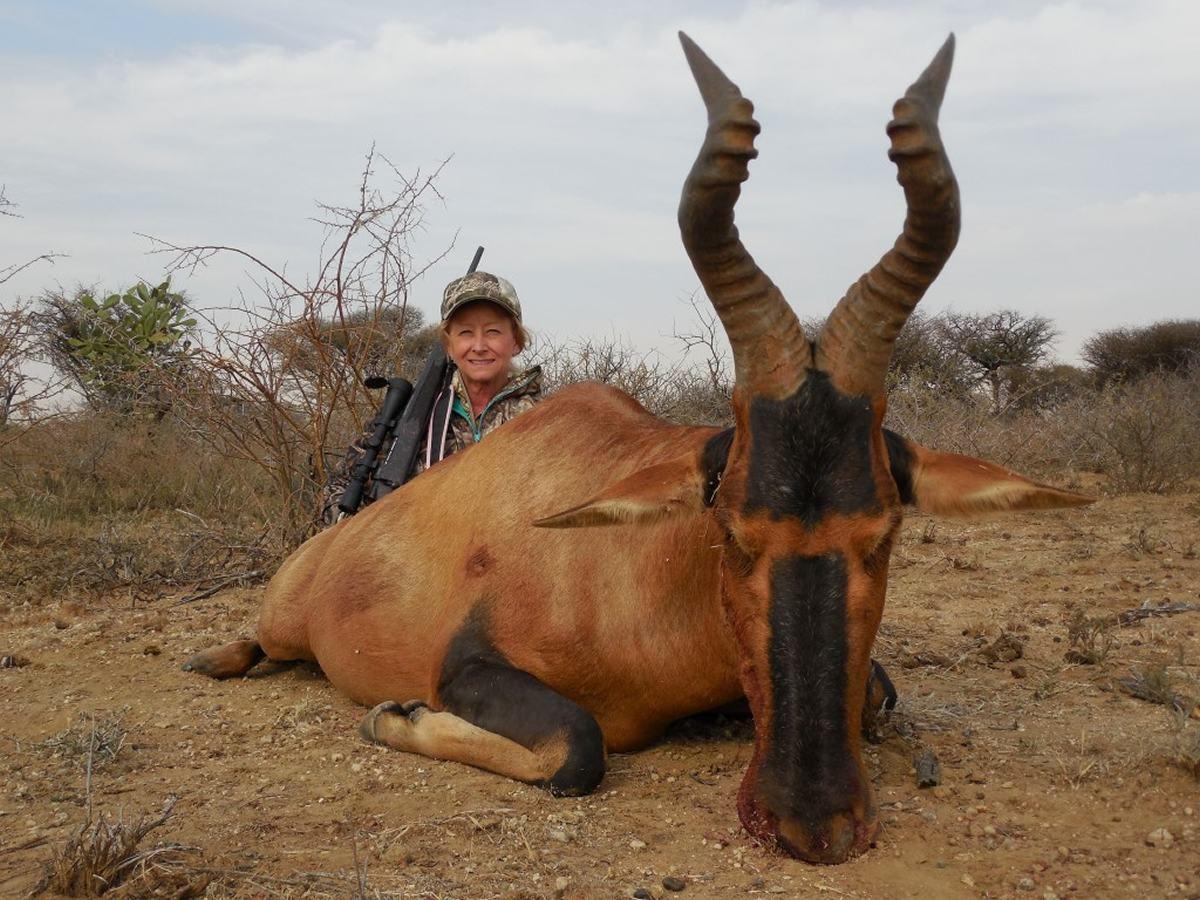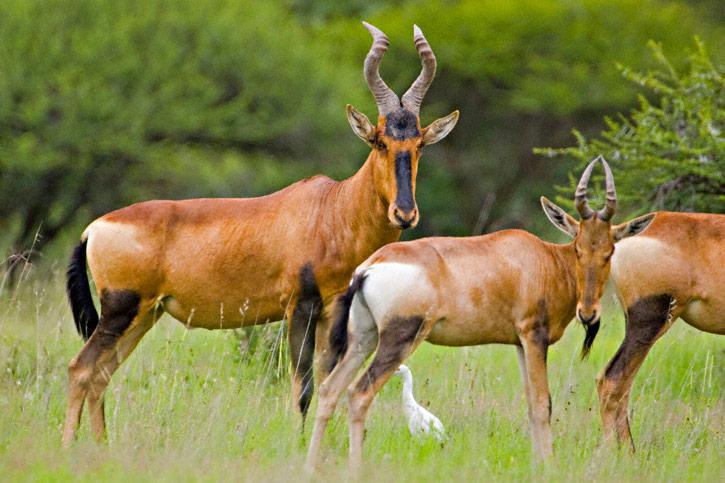The first image is the image on the left, the second image is the image on the right. Examine the images to the left and right. Is the description "In one of the images there is a person posing behind an antelope." accurate? Answer yes or no. Yes. The first image is the image on the left, the second image is the image on the right. Considering the images on both sides, is "A hunter with a gun poses behind a downed horned animal in one image." valid? Answer yes or no. Yes. 